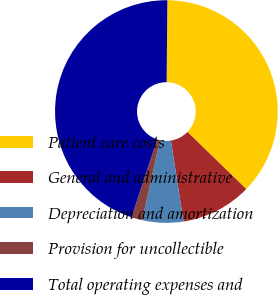<chart> <loc_0><loc_0><loc_500><loc_500><pie_chart><fcel>Patient care costs<fcel>General and administrative<fcel>Depreciation and amortization<fcel>Provision for uncollectible<fcel>Total operating expenses and<nl><fcel>37.12%<fcel>10.29%<fcel>5.94%<fcel>1.59%<fcel>45.07%<nl></chart> 